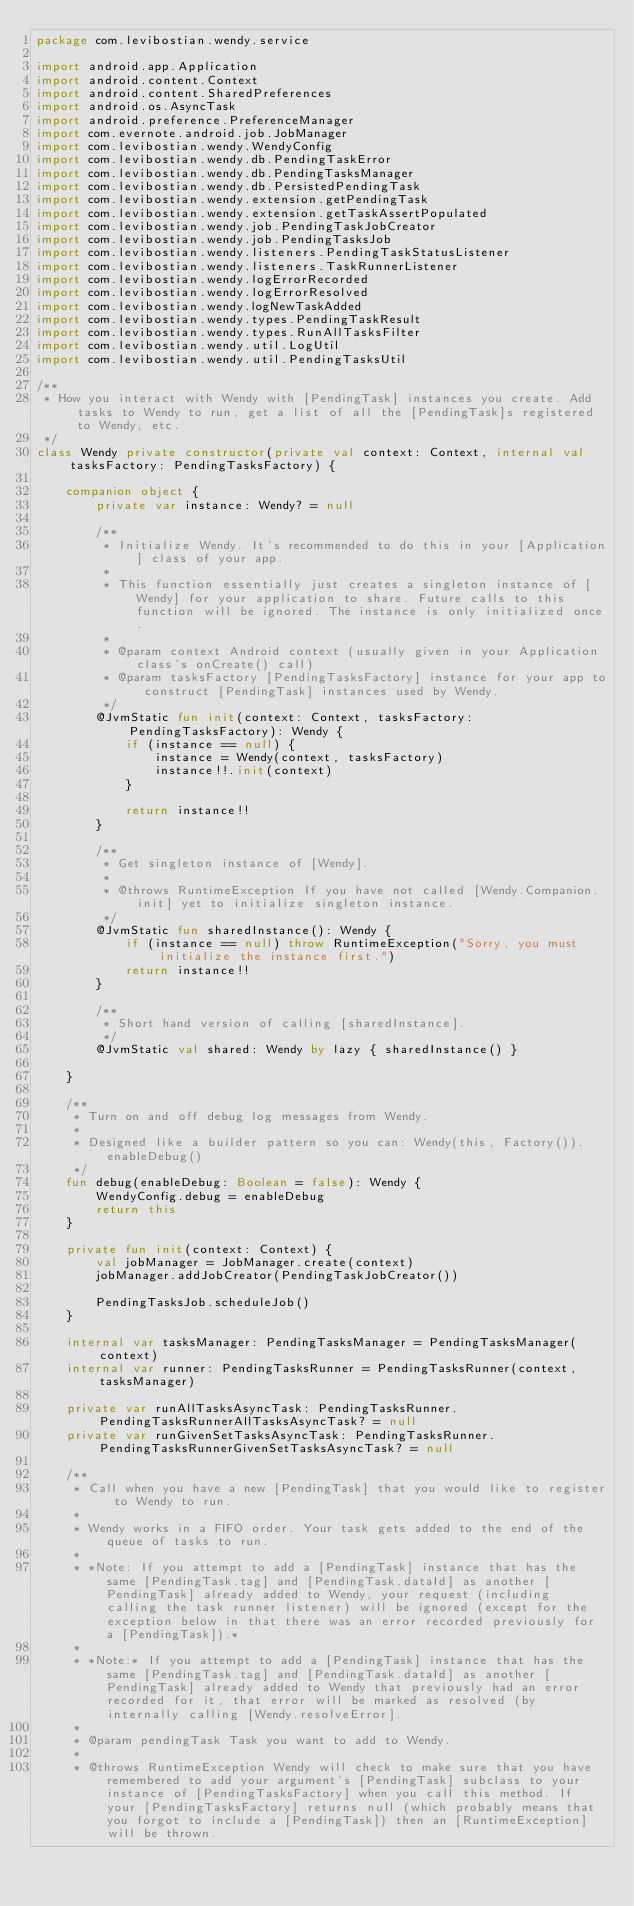Convert code to text. <code><loc_0><loc_0><loc_500><loc_500><_Kotlin_>package com.levibostian.wendy.service

import android.app.Application
import android.content.Context
import android.content.SharedPreferences
import android.os.AsyncTask
import android.preference.PreferenceManager
import com.evernote.android.job.JobManager
import com.levibostian.wendy.WendyConfig
import com.levibostian.wendy.db.PendingTaskError
import com.levibostian.wendy.db.PendingTasksManager
import com.levibostian.wendy.db.PersistedPendingTask
import com.levibostian.wendy.extension.getPendingTask
import com.levibostian.wendy.extension.getTaskAssertPopulated
import com.levibostian.wendy.job.PendingTaskJobCreator
import com.levibostian.wendy.job.PendingTasksJob
import com.levibostian.wendy.listeners.PendingTaskStatusListener
import com.levibostian.wendy.listeners.TaskRunnerListener
import com.levibostian.wendy.logErrorRecorded
import com.levibostian.wendy.logErrorResolved
import com.levibostian.wendy.logNewTaskAdded
import com.levibostian.wendy.types.PendingTaskResult
import com.levibostian.wendy.types.RunAllTasksFilter
import com.levibostian.wendy.util.LogUtil
import com.levibostian.wendy.util.PendingTasksUtil

/**
 * How you interact with Wendy with [PendingTask] instances you create. Add tasks to Wendy to run, get a list of all the [PendingTask]s registered to Wendy, etc.
 */
class Wendy private constructor(private val context: Context, internal val tasksFactory: PendingTasksFactory) {

    companion object {
        private var instance: Wendy? = null

        /**
         * Initialize Wendy. It's recommended to do this in your [Application] class of your app.
         *
         * This function essentially just creates a singleton instance of [Wendy] for your application to share. Future calls to this function will be ignored. The instance is only initialized once.
         *
         * @param context Android context (usually given in your Application class's onCreate() call)
         * @param tasksFactory [PendingTasksFactory] instance for your app to construct [PendingTask] instances used by Wendy.
         */
        @JvmStatic fun init(context: Context, tasksFactory: PendingTasksFactory): Wendy {
            if (instance == null) {
                instance = Wendy(context, tasksFactory)
                instance!!.init(context)
            }

            return instance!!
        }

        /**
         * Get singleton instance of [Wendy].
         *
         * @throws RuntimeException If you have not called [Wendy.Companion.init] yet to initialize singleton instance.
         */
        @JvmStatic fun sharedInstance(): Wendy {
            if (instance == null) throw RuntimeException("Sorry, you must initialize the instance first.")
            return instance!!
        }

        /**
         * Short hand version of calling [sharedInstance].
         */
        @JvmStatic val shared: Wendy by lazy { sharedInstance() }

    }

    /**
     * Turn on and off debug log messages from Wendy.
     *
     * Designed like a builder pattern so you can: Wendy(this, Factory()).enableDebug()
     */
    fun debug(enableDebug: Boolean = false): Wendy {
        WendyConfig.debug = enableDebug
        return this
    }

    private fun init(context: Context) {
        val jobManager = JobManager.create(context)
        jobManager.addJobCreator(PendingTaskJobCreator())

        PendingTasksJob.scheduleJob()
    }

    internal var tasksManager: PendingTasksManager = PendingTasksManager(context)
    internal var runner: PendingTasksRunner = PendingTasksRunner(context, tasksManager)

    private var runAllTasksAsyncTask: PendingTasksRunner.PendingTasksRunnerAllTasksAsyncTask? = null
    private var runGivenSetTasksAsyncTask: PendingTasksRunner.PendingTasksRunnerGivenSetTasksAsyncTask? = null

    /**
     * Call when you have a new [PendingTask] that you would like to register to Wendy to run.
     *
     * Wendy works in a FIFO order. Your task gets added to the end of the queue of tasks to run.
     *
     * *Note: If you attempt to add a [PendingTask] instance that has the same [PendingTask.tag] and [PendingTask.dataId] as another [PendingTask] already added to Wendy, your request (including calling the task runner listener) will be ignored (except for the exception below in that there was an error recorded previously for a [PendingTask]).*
     *
     * *Note:* If you attempt to add a [PendingTask] instance that has the same [PendingTask.tag] and [PendingTask.dataId] as another [PendingTask] already added to Wendy that previously had an error recorded for it, that error will be marked as resolved (by internally calling [Wendy.resolveError].
     *
     * @param pendingTask Task you want to add to Wendy.
     *
     * @throws RuntimeException Wendy will check to make sure that you have remembered to add your argument's [PendingTask] subclass to your instance of [PendingTasksFactory] when you call this method. If your [PendingTasksFactory] returns null (which probably means that you forgot to include a [PendingTask]) then an [RuntimeException] will be thrown.</code> 